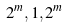<formula> <loc_0><loc_0><loc_500><loc_500>2 ^ { m } , 1 , 2 ^ { m }</formula> 